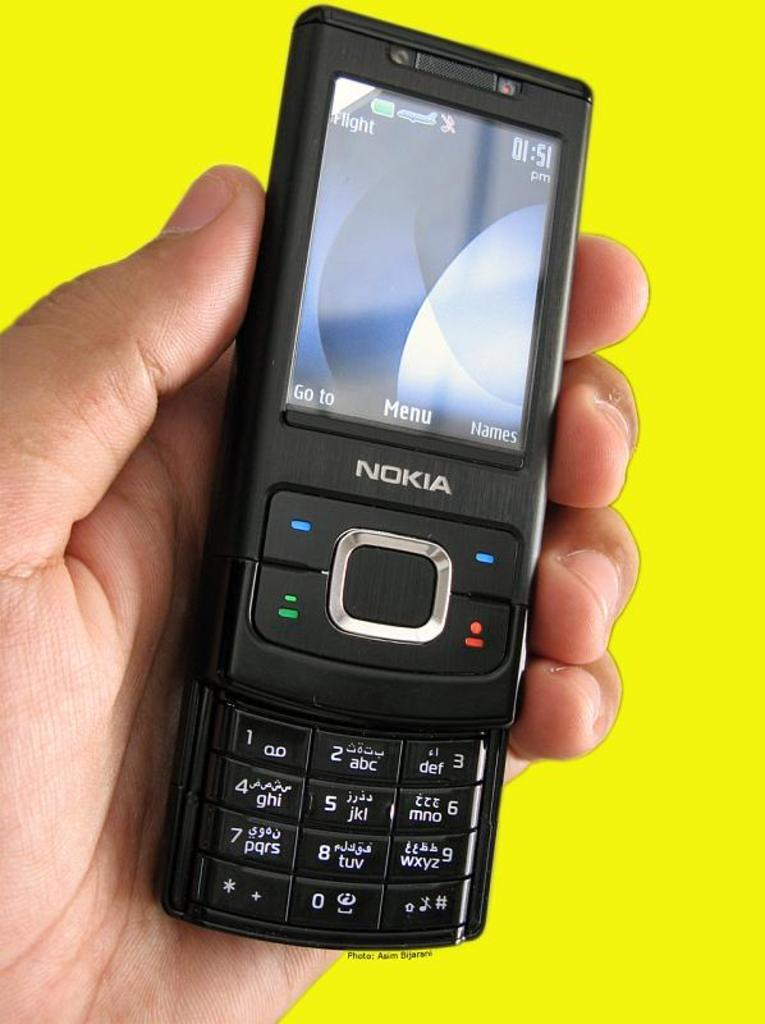<image>
Write a terse but informative summary of the picture. A Nokia phone on the home screen that has a Go To button and a Menu button. 